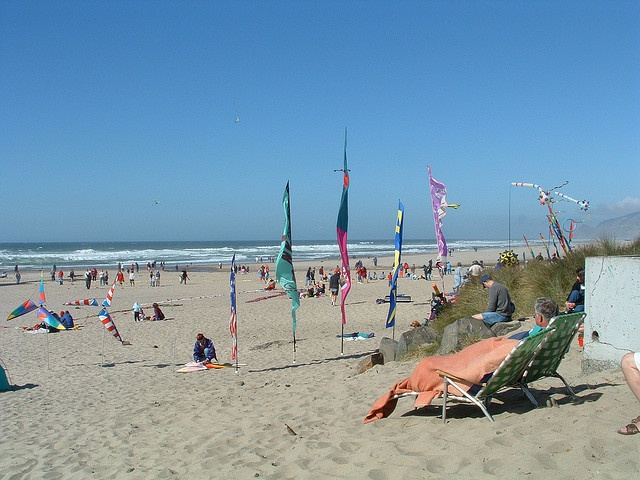Describe the objects in this image and their specific colors. I can see people in gray, darkgray, black, and lightgray tones, chair in gray, black, darkgray, and white tones, chair in gray, black, and darkgreen tones, kite in gray, lightblue, blue, darkgray, and purple tones, and kite in gray, teal, and black tones in this image. 